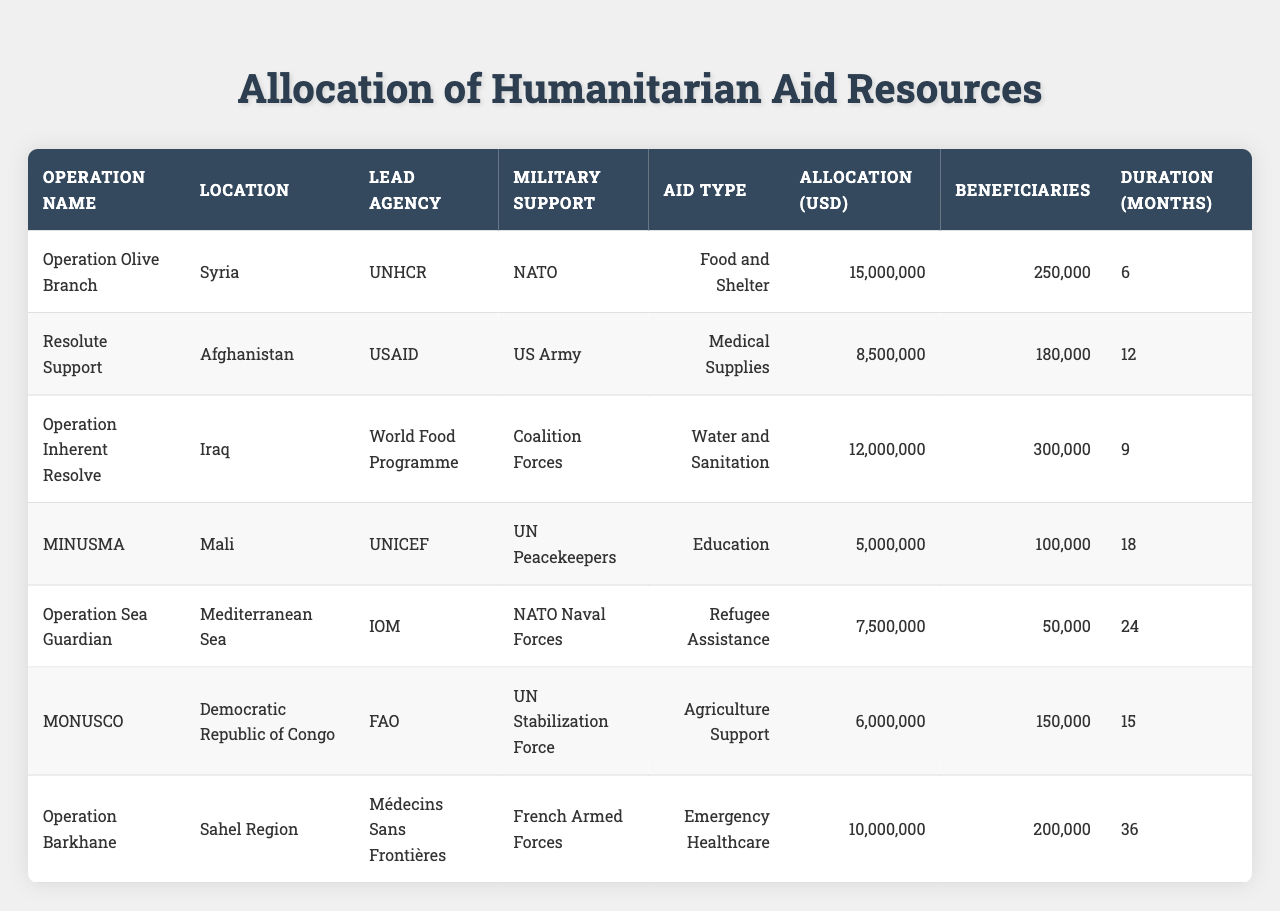What is the total allocation of humanitarian aid resources in Operation Olive Branch? The table shows that the allocation for Operation Olive Branch in Syria is 15,000,000 USD.
Answer: 15,000,000 USD How many beneficiaries were served by the Resolute Support operation? According to the table, the Resolute Support operation in Afghanistan served 180,000 beneficiaries.
Answer: 180,000 beneficiaries Which operation provided education support? The table lists MINUSMA in Mali as the operation that provided education support through UNICEF.
Answer: MINUSMA What is the average allocation of aid across all operations? To find the average, sum all allocations (15,000,000 + 8,500,000 + 12,000,000 + 5,000,000 + 7,500,000 + 6,000,000 + 10,000,000 = 64,000,000) and divide by the number of operations (7). The average allocation is 64,000,000 / 7 = 9,142,857.14.
Answer: 9,142,857.14 USD Which operation has the longest duration? The longest duration in the table is for Operation Barkhane, which has a duration of 36 months.
Answer: Operation Barkhane Was UNICEF involved in any operations providing medical supplies? The table does not list UNICEF as being involved in providing medical supplies; the lead agency for that type of aid is USAID in the Resolute Support operation.
Answer: No How many months of aid were provided in total across all operations? To get the total duration, sum all durations: (6 + 12 + 9 + 18 + 24 + 15 + 36 = 120). The total duration across all operations is 120 months.
Answer: 120 months Which operation had the least allocation of funds, and how much was allocated? The table shows that MINUSMA had the least allocation, with 5,000,000 USD designated for education support.
Answer: MINUSMA, 5,000,000 USD How many beneficiaries were served in the Operation Sea Guardian compared to Operation Barkhane? Operation Sea Guardian served 50,000 beneficiaries and Operation Barkhane served 200,000 beneficiaries. Comparing these numbers, Operation Barkhane served more beneficiaries by (200,000 - 50,000 = 150,000).
Answer: Operation Barkhane served 150,000 more beneficiaries What percentage of the total allocation was used for Water and Sanitation aid? First, identify the Water and Sanitation allocation which is 12,000,000 USD. The total allocation is 64,000,000 USD. Calculate the percentage: (12,000,000 / 64,000,000) * 100= 18.75%.
Answer: 18.75% 